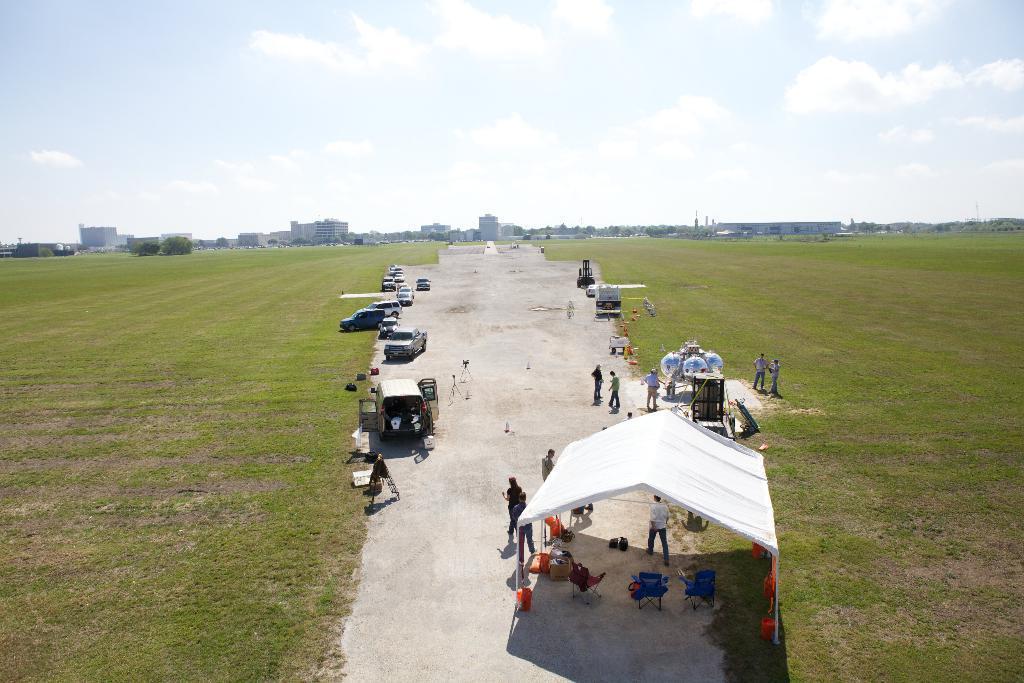How would you summarize this image in a sentence or two? In this picture we can see vehicles on the road, tent, chairs and some people standing, grass, buildings, trees and some objects and in the background we can see the sky with clouds. 